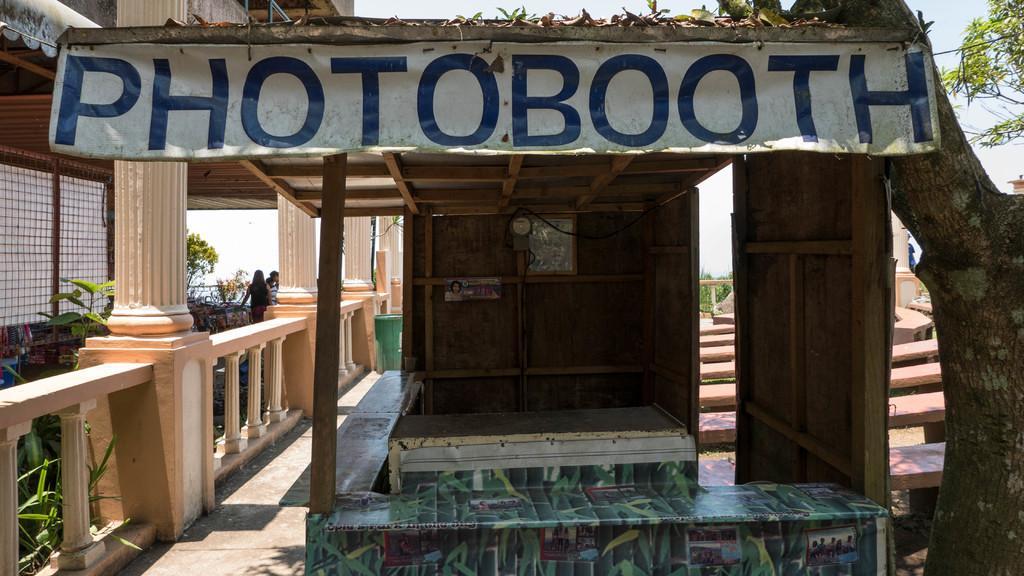How would you summarize this image in a sentence or two? In this image there is a photo booth in the middle. At the top there is a banner. On the left side there is a building. There is a cement railing on the left side. On the right side there is a tree. In the background there are steps. On the left side there are few people standing in the background. There is a grill on the left side top. 